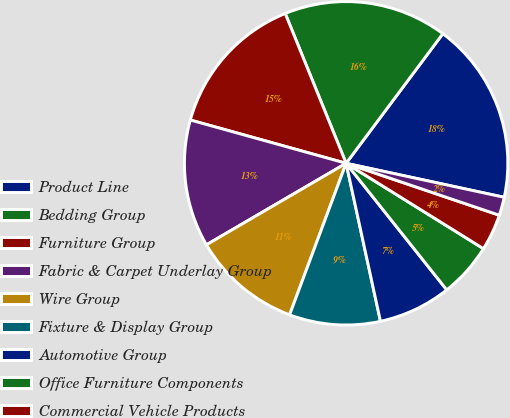<chart> <loc_0><loc_0><loc_500><loc_500><pie_chart><fcel>Product Line<fcel>Bedding Group<fcel>Furniture Group<fcel>Fabric & Carpet Underlay Group<fcel>Wire Group<fcel>Fixture & Display Group<fcel>Automotive Group<fcel>Office Furniture Components<fcel>Commercial Vehicle Products<fcel>Machinery Group<nl><fcel>18.17%<fcel>16.35%<fcel>14.54%<fcel>12.72%<fcel>10.91%<fcel>9.09%<fcel>7.28%<fcel>5.46%<fcel>3.65%<fcel>1.83%<nl></chart> 